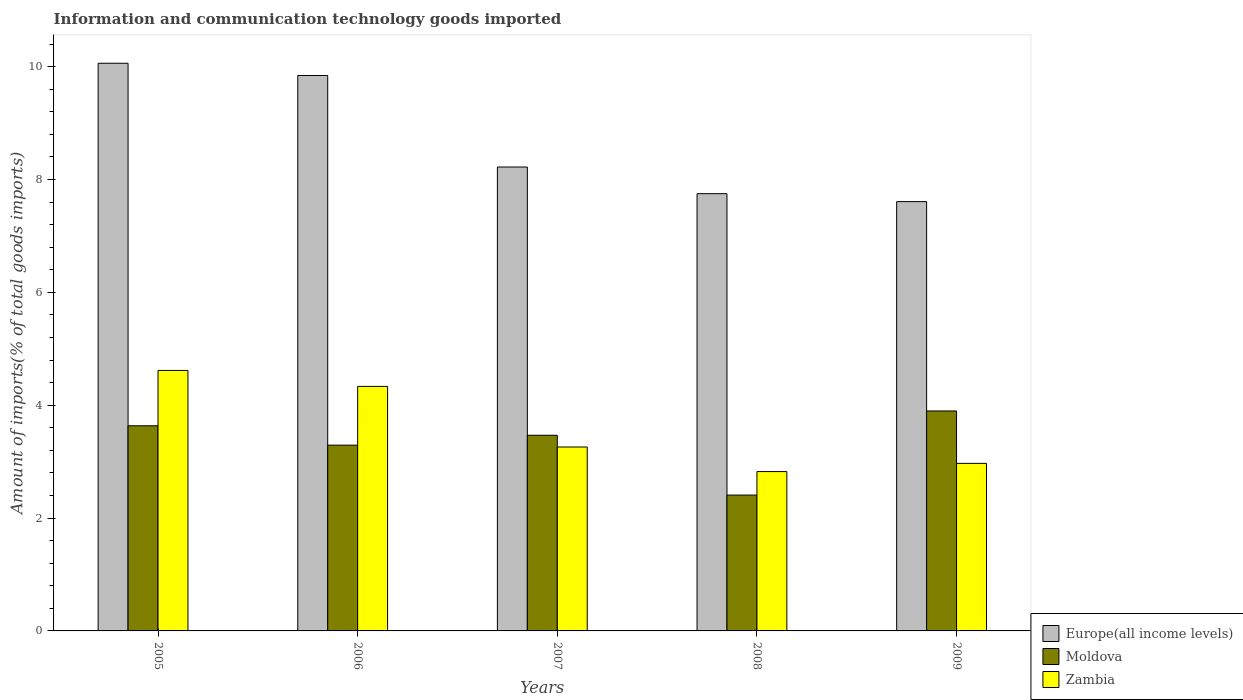How many groups of bars are there?
Provide a short and direct response. 5. Are the number of bars per tick equal to the number of legend labels?
Offer a very short reply. Yes. What is the label of the 1st group of bars from the left?
Provide a succinct answer. 2005. What is the amount of goods imported in Zambia in 2006?
Provide a succinct answer. 4.33. Across all years, what is the maximum amount of goods imported in Europe(all income levels)?
Your response must be concise. 10.06. Across all years, what is the minimum amount of goods imported in Europe(all income levels)?
Your response must be concise. 7.61. In which year was the amount of goods imported in Zambia maximum?
Offer a very short reply. 2005. What is the total amount of goods imported in Zambia in the graph?
Offer a very short reply. 18. What is the difference between the amount of goods imported in Europe(all income levels) in 2005 and that in 2007?
Your response must be concise. 1.84. What is the difference between the amount of goods imported in Europe(all income levels) in 2007 and the amount of goods imported in Zambia in 2005?
Your answer should be very brief. 3.6. What is the average amount of goods imported in Europe(all income levels) per year?
Provide a short and direct response. 8.7. In the year 2008, what is the difference between the amount of goods imported in Moldova and amount of goods imported in Europe(all income levels)?
Your answer should be compact. -5.34. In how many years, is the amount of goods imported in Zambia greater than 0.4 %?
Offer a very short reply. 5. What is the ratio of the amount of goods imported in Europe(all income levels) in 2005 to that in 2008?
Make the answer very short. 1.3. Is the difference between the amount of goods imported in Moldova in 2006 and 2007 greater than the difference between the amount of goods imported in Europe(all income levels) in 2006 and 2007?
Offer a very short reply. No. What is the difference between the highest and the second highest amount of goods imported in Zambia?
Offer a very short reply. 0.28. What is the difference between the highest and the lowest amount of goods imported in Europe(all income levels)?
Make the answer very short. 2.45. What does the 1st bar from the left in 2009 represents?
Provide a succinct answer. Europe(all income levels). What does the 1st bar from the right in 2005 represents?
Provide a short and direct response. Zambia. Is it the case that in every year, the sum of the amount of goods imported in Moldova and amount of goods imported in Zambia is greater than the amount of goods imported in Europe(all income levels)?
Provide a short and direct response. No. How many bars are there?
Provide a short and direct response. 15. What is the difference between two consecutive major ticks on the Y-axis?
Provide a succinct answer. 2. Does the graph contain any zero values?
Offer a terse response. No. Does the graph contain grids?
Offer a terse response. No. Where does the legend appear in the graph?
Your response must be concise. Bottom right. How are the legend labels stacked?
Your answer should be very brief. Vertical. What is the title of the graph?
Ensure brevity in your answer.  Information and communication technology goods imported. Does "French Polynesia" appear as one of the legend labels in the graph?
Your answer should be very brief. No. What is the label or title of the X-axis?
Provide a succinct answer. Years. What is the label or title of the Y-axis?
Your answer should be very brief. Amount of imports(% of total goods imports). What is the Amount of imports(% of total goods imports) in Europe(all income levels) in 2005?
Your response must be concise. 10.06. What is the Amount of imports(% of total goods imports) in Moldova in 2005?
Make the answer very short. 3.63. What is the Amount of imports(% of total goods imports) of Zambia in 2005?
Your response must be concise. 4.62. What is the Amount of imports(% of total goods imports) in Europe(all income levels) in 2006?
Keep it short and to the point. 9.84. What is the Amount of imports(% of total goods imports) of Moldova in 2006?
Give a very brief answer. 3.29. What is the Amount of imports(% of total goods imports) of Zambia in 2006?
Your answer should be very brief. 4.33. What is the Amount of imports(% of total goods imports) in Europe(all income levels) in 2007?
Offer a very short reply. 8.22. What is the Amount of imports(% of total goods imports) of Moldova in 2007?
Your response must be concise. 3.47. What is the Amount of imports(% of total goods imports) of Zambia in 2007?
Give a very brief answer. 3.26. What is the Amount of imports(% of total goods imports) of Europe(all income levels) in 2008?
Ensure brevity in your answer.  7.75. What is the Amount of imports(% of total goods imports) of Moldova in 2008?
Your response must be concise. 2.41. What is the Amount of imports(% of total goods imports) of Zambia in 2008?
Your response must be concise. 2.82. What is the Amount of imports(% of total goods imports) of Europe(all income levels) in 2009?
Provide a succinct answer. 7.61. What is the Amount of imports(% of total goods imports) of Moldova in 2009?
Your answer should be very brief. 3.9. What is the Amount of imports(% of total goods imports) in Zambia in 2009?
Your answer should be compact. 2.97. Across all years, what is the maximum Amount of imports(% of total goods imports) in Europe(all income levels)?
Keep it short and to the point. 10.06. Across all years, what is the maximum Amount of imports(% of total goods imports) of Moldova?
Ensure brevity in your answer.  3.9. Across all years, what is the maximum Amount of imports(% of total goods imports) of Zambia?
Provide a succinct answer. 4.62. Across all years, what is the minimum Amount of imports(% of total goods imports) of Europe(all income levels)?
Your answer should be very brief. 7.61. Across all years, what is the minimum Amount of imports(% of total goods imports) of Moldova?
Make the answer very short. 2.41. Across all years, what is the minimum Amount of imports(% of total goods imports) in Zambia?
Make the answer very short. 2.82. What is the total Amount of imports(% of total goods imports) of Europe(all income levels) in the graph?
Provide a short and direct response. 43.48. What is the total Amount of imports(% of total goods imports) in Moldova in the graph?
Make the answer very short. 16.7. What is the total Amount of imports(% of total goods imports) of Zambia in the graph?
Your answer should be very brief. 18. What is the difference between the Amount of imports(% of total goods imports) of Europe(all income levels) in 2005 and that in 2006?
Provide a succinct answer. 0.22. What is the difference between the Amount of imports(% of total goods imports) of Moldova in 2005 and that in 2006?
Give a very brief answer. 0.34. What is the difference between the Amount of imports(% of total goods imports) in Zambia in 2005 and that in 2006?
Give a very brief answer. 0.28. What is the difference between the Amount of imports(% of total goods imports) in Europe(all income levels) in 2005 and that in 2007?
Keep it short and to the point. 1.84. What is the difference between the Amount of imports(% of total goods imports) in Moldova in 2005 and that in 2007?
Offer a terse response. 0.17. What is the difference between the Amount of imports(% of total goods imports) of Zambia in 2005 and that in 2007?
Offer a terse response. 1.36. What is the difference between the Amount of imports(% of total goods imports) in Europe(all income levels) in 2005 and that in 2008?
Provide a short and direct response. 2.31. What is the difference between the Amount of imports(% of total goods imports) in Moldova in 2005 and that in 2008?
Keep it short and to the point. 1.23. What is the difference between the Amount of imports(% of total goods imports) in Zambia in 2005 and that in 2008?
Provide a short and direct response. 1.79. What is the difference between the Amount of imports(% of total goods imports) of Europe(all income levels) in 2005 and that in 2009?
Provide a short and direct response. 2.45. What is the difference between the Amount of imports(% of total goods imports) of Moldova in 2005 and that in 2009?
Give a very brief answer. -0.26. What is the difference between the Amount of imports(% of total goods imports) in Zambia in 2005 and that in 2009?
Ensure brevity in your answer.  1.65. What is the difference between the Amount of imports(% of total goods imports) in Europe(all income levels) in 2006 and that in 2007?
Offer a very short reply. 1.62. What is the difference between the Amount of imports(% of total goods imports) in Moldova in 2006 and that in 2007?
Your response must be concise. -0.18. What is the difference between the Amount of imports(% of total goods imports) in Zambia in 2006 and that in 2007?
Ensure brevity in your answer.  1.07. What is the difference between the Amount of imports(% of total goods imports) of Europe(all income levels) in 2006 and that in 2008?
Give a very brief answer. 2.09. What is the difference between the Amount of imports(% of total goods imports) of Moldova in 2006 and that in 2008?
Offer a terse response. 0.88. What is the difference between the Amount of imports(% of total goods imports) in Zambia in 2006 and that in 2008?
Offer a very short reply. 1.51. What is the difference between the Amount of imports(% of total goods imports) in Europe(all income levels) in 2006 and that in 2009?
Keep it short and to the point. 2.23. What is the difference between the Amount of imports(% of total goods imports) of Moldova in 2006 and that in 2009?
Provide a succinct answer. -0.61. What is the difference between the Amount of imports(% of total goods imports) in Zambia in 2006 and that in 2009?
Provide a short and direct response. 1.36. What is the difference between the Amount of imports(% of total goods imports) of Europe(all income levels) in 2007 and that in 2008?
Your response must be concise. 0.47. What is the difference between the Amount of imports(% of total goods imports) in Moldova in 2007 and that in 2008?
Provide a succinct answer. 1.06. What is the difference between the Amount of imports(% of total goods imports) in Zambia in 2007 and that in 2008?
Provide a short and direct response. 0.44. What is the difference between the Amount of imports(% of total goods imports) of Europe(all income levels) in 2007 and that in 2009?
Give a very brief answer. 0.61. What is the difference between the Amount of imports(% of total goods imports) in Moldova in 2007 and that in 2009?
Provide a succinct answer. -0.43. What is the difference between the Amount of imports(% of total goods imports) of Zambia in 2007 and that in 2009?
Your response must be concise. 0.29. What is the difference between the Amount of imports(% of total goods imports) in Europe(all income levels) in 2008 and that in 2009?
Your response must be concise. 0.14. What is the difference between the Amount of imports(% of total goods imports) of Moldova in 2008 and that in 2009?
Your answer should be very brief. -1.49. What is the difference between the Amount of imports(% of total goods imports) in Zambia in 2008 and that in 2009?
Offer a terse response. -0.15. What is the difference between the Amount of imports(% of total goods imports) in Europe(all income levels) in 2005 and the Amount of imports(% of total goods imports) in Moldova in 2006?
Provide a short and direct response. 6.77. What is the difference between the Amount of imports(% of total goods imports) of Europe(all income levels) in 2005 and the Amount of imports(% of total goods imports) of Zambia in 2006?
Your response must be concise. 5.73. What is the difference between the Amount of imports(% of total goods imports) of Moldova in 2005 and the Amount of imports(% of total goods imports) of Zambia in 2006?
Offer a terse response. -0.7. What is the difference between the Amount of imports(% of total goods imports) of Europe(all income levels) in 2005 and the Amount of imports(% of total goods imports) of Moldova in 2007?
Your response must be concise. 6.59. What is the difference between the Amount of imports(% of total goods imports) in Europe(all income levels) in 2005 and the Amount of imports(% of total goods imports) in Zambia in 2007?
Offer a very short reply. 6.8. What is the difference between the Amount of imports(% of total goods imports) of Moldova in 2005 and the Amount of imports(% of total goods imports) of Zambia in 2007?
Provide a short and direct response. 0.38. What is the difference between the Amount of imports(% of total goods imports) in Europe(all income levels) in 2005 and the Amount of imports(% of total goods imports) in Moldova in 2008?
Offer a terse response. 7.65. What is the difference between the Amount of imports(% of total goods imports) of Europe(all income levels) in 2005 and the Amount of imports(% of total goods imports) of Zambia in 2008?
Offer a very short reply. 7.24. What is the difference between the Amount of imports(% of total goods imports) in Moldova in 2005 and the Amount of imports(% of total goods imports) in Zambia in 2008?
Offer a very short reply. 0.81. What is the difference between the Amount of imports(% of total goods imports) in Europe(all income levels) in 2005 and the Amount of imports(% of total goods imports) in Moldova in 2009?
Give a very brief answer. 6.16. What is the difference between the Amount of imports(% of total goods imports) of Europe(all income levels) in 2005 and the Amount of imports(% of total goods imports) of Zambia in 2009?
Ensure brevity in your answer.  7.09. What is the difference between the Amount of imports(% of total goods imports) of Moldova in 2005 and the Amount of imports(% of total goods imports) of Zambia in 2009?
Offer a very short reply. 0.67. What is the difference between the Amount of imports(% of total goods imports) of Europe(all income levels) in 2006 and the Amount of imports(% of total goods imports) of Moldova in 2007?
Offer a terse response. 6.37. What is the difference between the Amount of imports(% of total goods imports) of Europe(all income levels) in 2006 and the Amount of imports(% of total goods imports) of Zambia in 2007?
Provide a succinct answer. 6.58. What is the difference between the Amount of imports(% of total goods imports) of Moldova in 2006 and the Amount of imports(% of total goods imports) of Zambia in 2007?
Ensure brevity in your answer.  0.03. What is the difference between the Amount of imports(% of total goods imports) in Europe(all income levels) in 2006 and the Amount of imports(% of total goods imports) in Moldova in 2008?
Your response must be concise. 7.43. What is the difference between the Amount of imports(% of total goods imports) in Europe(all income levels) in 2006 and the Amount of imports(% of total goods imports) in Zambia in 2008?
Provide a short and direct response. 7.02. What is the difference between the Amount of imports(% of total goods imports) of Moldova in 2006 and the Amount of imports(% of total goods imports) of Zambia in 2008?
Your response must be concise. 0.47. What is the difference between the Amount of imports(% of total goods imports) in Europe(all income levels) in 2006 and the Amount of imports(% of total goods imports) in Moldova in 2009?
Keep it short and to the point. 5.94. What is the difference between the Amount of imports(% of total goods imports) of Europe(all income levels) in 2006 and the Amount of imports(% of total goods imports) of Zambia in 2009?
Give a very brief answer. 6.87. What is the difference between the Amount of imports(% of total goods imports) of Moldova in 2006 and the Amount of imports(% of total goods imports) of Zambia in 2009?
Offer a very short reply. 0.32. What is the difference between the Amount of imports(% of total goods imports) in Europe(all income levels) in 2007 and the Amount of imports(% of total goods imports) in Moldova in 2008?
Your answer should be compact. 5.81. What is the difference between the Amount of imports(% of total goods imports) in Europe(all income levels) in 2007 and the Amount of imports(% of total goods imports) in Zambia in 2008?
Offer a terse response. 5.4. What is the difference between the Amount of imports(% of total goods imports) in Moldova in 2007 and the Amount of imports(% of total goods imports) in Zambia in 2008?
Offer a terse response. 0.64. What is the difference between the Amount of imports(% of total goods imports) in Europe(all income levels) in 2007 and the Amount of imports(% of total goods imports) in Moldova in 2009?
Your answer should be compact. 4.32. What is the difference between the Amount of imports(% of total goods imports) in Europe(all income levels) in 2007 and the Amount of imports(% of total goods imports) in Zambia in 2009?
Provide a short and direct response. 5.25. What is the difference between the Amount of imports(% of total goods imports) in Moldova in 2007 and the Amount of imports(% of total goods imports) in Zambia in 2009?
Ensure brevity in your answer.  0.5. What is the difference between the Amount of imports(% of total goods imports) in Europe(all income levels) in 2008 and the Amount of imports(% of total goods imports) in Moldova in 2009?
Offer a terse response. 3.85. What is the difference between the Amount of imports(% of total goods imports) of Europe(all income levels) in 2008 and the Amount of imports(% of total goods imports) of Zambia in 2009?
Provide a short and direct response. 4.78. What is the difference between the Amount of imports(% of total goods imports) in Moldova in 2008 and the Amount of imports(% of total goods imports) in Zambia in 2009?
Ensure brevity in your answer.  -0.56. What is the average Amount of imports(% of total goods imports) in Europe(all income levels) per year?
Keep it short and to the point. 8.7. What is the average Amount of imports(% of total goods imports) in Moldova per year?
Keep it short and to the point. 3.34. What is the average Amount of imports(% of total goods imports) of Zambia per year?
Provide a succinct answer. 3.6. In the year 2005, what is the difference between the Amount of imports(% of total goods imports) in Europe(all income levels) and Amount of imports(% of total goods imports) in Moldova?
Make the answer very short. 6.42. In the year 2005, what is the difference between the Amount of imports(% of total goods imports) of Europe(all income levels) and Amount of imports(% of total goods imports) of Zambia?
Ensure brevity in your answer.  5.44. In the year 2005, what is the difference between the Amount of imports(% of total goods imports) of Moldova and Amount of imports(% of total goods imports) of Zambia?
Provide a succinct answer. -0.98. In the year 2006, what is the difference between the Amount of imports(% of total goods imports) of Europe(all income levels) and Amount of imports(% of total goods imports) of Moldova?
Provide a succinct answer. 6.55. In the year 2006, what is the difference between the Amount of imports(% of total goods imports) of Europe(all income levels) and Amount of imports(% of total goods imports) of Zambia?
Give a very brief answer. 5.51. In the year 2006, what is the difference between the Amount of imports(% of total goods imports) of Moldova and Amount of imports(% of total goods imports) of Zambia?
Offer a terse response. -1.04. In the year 2007, what is the difference between the Amount of imports(% of total goods imports) of Europe(all income levels) and Amount of imports(% of total goods imports) of Moldova?
Provide a succinct answer. 4.75. In the year 2007, what is the difference between the Amount of imports(% of total goods imports) of Europe(all income levels) and Amount of imports(% of total goods imports) of Zambia?
Your response must be concise. 4.96. In the year 2007, what is the difference between the Amount of imports(% of total goods imports) of Moldova and Amount of imports(% of total goods imports) of Zambia?
Offer a very short reply. 0.21. In the year 2008, what is the difference between the Amount of imports(% of total goods imports) of Europe(all income levels) and Amount of imports(% of total goods imports) of Moldova?
Offer a very short reply. 5.34. In the year 2008, what is the difference between the Amount of imports(% of total goods imports) in Europe(all income levels) and Amount of imports(% of total goods imports) in Zambia?
Ensure brevity in your answer.  4.92. In the year 2008, what is the difference between the Amount of imports(% of total goods imports) in Moldova and Amount of imports(% of total goods imports) in Zambia?
Offer a very short reply. -0.42. In the year 2009, what is the difference between the Amount of imports(% of total goods imports) of Europe(all income levels) and Amount of imports(% of total goods imports) of Moldova?
Offer a very short reply. 3.71. In the year 2009, what is the difference between the Amount of imports(% of total goods imports) of Europe(all income levels) and Amount of imports(% of total goods imports) of Zambia?
Offer a terse response. 4.64. In the year 2009, what is the difference between the Amount of imports(% of total goods imports) in Moldova and Amount of imports(% of total goods imports) in Zambia?
Offer a terse response. 0.93. What is the ratio of the Amount of imports(% of total goods imports) in Europe(all income levels) in 2005 to that in 2006?
Keep it short and to the point. 1.02. What is the ratio of the Amount of imports(% of total goods imports) in Moldova in 2005 to that in 2006?
Make the answer very short. 1.1. What is the ratio of the Amount of imports(% of total goods imports) of Zambia in 2005 to that in 2006?
Keep it short and to the point. 1.07. What is the ratio of the Amount of imports(% of total goods imports) in Europe(all income levels) in 2005 to that in 2007?
Offer a very short reply. 1.22. What is the ratio of the Amount of imports(% of total goods imports) in Moldova in 2005 to that in 2007?
Give a very brief answer. 1.05. What is the ratio of the Amount of imports(% of total goods imports) of Zambia in 2005 to that in 2007?
Keep it short and to the point. 1.42. What is the ratio of the Amount of imports(% of total goods imports) of Europe(all income levels) in 2005 to that in 2008?
Offer a very short reply. 1.3. What is the ratio of the Amount of imports(% of total goods imports) in Moldova in 2005 to that in 2008?
Give a very brief answer. 1.51. What is the ratio of the Amount of imports(% of total goods imports) in Zambia in 2005 to that in 2008?
Provide a succinct answer. 1.63. What is the ratio of the Amount of imports(% of total goods imports) of Europe(all income levels) in 2005 to that in 2009?
Give a very brief answer. 1.32. What is the ratio of the Amount of imports(% of total goods imports) of Moldova in 2005 to that in 2009?
Keep it short and to the point. 0.93. What is the ratio of the Amount of imports(% of total goods imports) of Zambia in 2005 to that in 2009?
Offer a terse response. 1.55. What is the ratio of the Amount of imports(% of total goods imports) in Europe(all income levels) in 2006 to that in 2007?
Keep it short and to the point. 1.2. What is the ratio of the Amount of imports(% of total goods imports) of Moldova in 2006 to that in 2007?
Provide a short and direct response. 0.95. What is the ratio of the Amount of imports(% of total goods imports) of Zambia in 2006 to that in 2007?
Your response must be concise. 1.33. What is the ratio of the Amount of imports(% of total goods imports) of Europe(all income levels) in 2006 to that in 2008?
Your answer should be compact. 1.27. What is the ratio of the Amount of imports(% of total goods imports) of Moldova in 2006 to that in 2008?
Your answer should be very brief. 1.37. What is the ratio of the Amount of imports(% of total goods imports) in Zambia in 2006 to that in 2008?
Provide a short and direct response. 1.53. What is the ratio of the Amount of imports(% of total goods imports) in Europe(all income levels) in 2006 to that in 2009?
Give a very brief answer. 1.29. What is the ratio of the Amount of imports(% of total goods imports) in Moldova in 2006 to that in 2009?
Your response must be concise. 0.84. What is the ratio of the Amount of imports(% of total goods imports) in Zambia in 2006 to that in 2009?
Give a very brief answer. 1.46. What is the ratio of the Amount of imports(% of total goods imports) in Europe(all income levels) in 2007 to that in 2008?
Provide a short and direct response. 1.06. What is the ratio of the Amount of imports(% of total goods imports) of Moldova in 2007 to that in 2008?
Provide a succinct answer. 1.44. What is the ratio of the Amount of imports(% of total goods imports) of Zambia in 2007 to that in 2008?
Your answer should be compact. 1.15. What is the ratio of the Amount of imports(% of total goods imports) in Europe(all income levels) in 2007 to that in 2009?
Provide a short and direct response. 1.08. What is the ratio of the Amount of imports(% of total goods imports) of Moldova in 2007 to that in 2009?
Your answer should be very brief. 0.89. What is the ratio of the Amount of imports(% of total goods imports) of Zambia in 2007 to that in 2009?
Make the answer very short. 1.1. What is the ratio of the Amount of imports(% of total goods imports) of Europe(all income levels) in 2008 to that in 2009?
Offer a terse response. 1.02. What is the ratio of the Amount of imports(% of total goods imports) of Moldova in 2008 to that in 2009?
Your response must be concise. 0.62. What is the ratio of the Amount of imports(% of total goods imports) of Zambia in 2008 to that in 2009?
Ensure brevity in your answer.  0.95. What is the difference between the highest and the second highest Amount of imports(% of total goods imports) in Europe(all income levels)?
Ensure brevity in your answer.  0.22. What is the difference between the highest and the second highest Amount of imports(% of total goods imports) of Moldova?
Keep it short and to the point. 0.26. What is the difference between the highest and the second highest Amount of imports(% of total goods imports) in Zambia?
Your answer should be compact. 0.28. What is the difference between the highest and the lowest Amount of imports(% of total goods imports) in Europe(all income levels)?
Ensure brevity in your answer.  2.45. What is the difference between the highest and the lowest Amount of imports(% of total goods imports) of Moldova?
Make the answer very short. 1.49. What is the difference between the highest and the lowest Amount of imports(% of total goods imports) in Zambia?
Offer a very short reply. 1.79. 